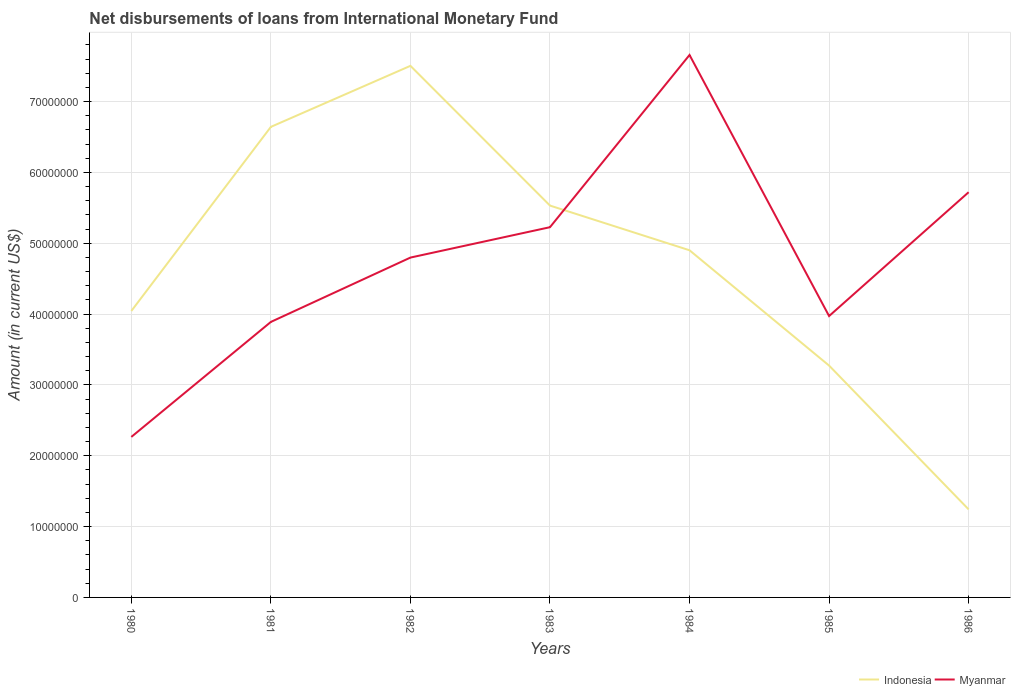Does the line corresponding to Myanmar intersect with the line corresponding to Indonesia?
Your answer should be compact. Yes. Across all years, what is the maximum amount of loans disbursed in Myanmar?
Provide a short and direct response. 2.27e+07. In which year was the amount of loans disbursed in Myanmar maximum?
Provide a short and direct response. 1980. What is the total amount of loans disbursed in Indonesia in the graph?
Give a very brief answer. 7.71e+06. What is the difference between the highest and the second highest amount of loans disbursed in Indonesia?
Give a very brief answer. 6.26e+07. Is the amount of loans disbursed in Indonesia strictly greater than the amount of loans disbursed in Myanmar over the years?
Offer a terse response. No. How many years are there in the graph?
Provide a short and direct response. 7. Does the graph contain grids?
Offer a terse response. Yes. Where does the legend appear in the graph?
Give a very brief answer. Bottom right. How are the legend labels stacked?
Provide a succinct answer. Horizontal. What is the title of the graph?
Make the answer very short. Net disbursements of loans from International Monetary Fund. What is the Amount (in current US$) in Indonesia in 1980?
Provide a short and direct response. 4.04e+07. What is the Amount (in current US$) of Myanmar in 1980?
Provide a succinct answer. 2.27e+07. What is the Amount (in current US$) of Indonesia in 1981?
Make the answer very short. 6.64e+07. What is the Amount (in current US$) in Myanmar in 1981?
Your answer should be very brief. 3.89e+07. What is the Amount (in current US$) in Indonesia in 1982?
Offer a very short reply. 7.50e+07. What is the Amount (in current US$) in Myanmar in 1982?
Offer a terse response. 4.80e+07. What is the Amount (in current US$) of Indonesia in 1983?
Keep it short and to the point. 5.53e+07. What is the Amount (in current US$) in Myanmar in 1983?
Your response must be concise. 5.23e+07. What is the Amount (in current US$) of Indonesia in 1984?
Make the answer very short. 4.90e+07. What is the Amount (in current US$) of Myanmar in 1984?
Ensure brevity in your answer.  7.66e+07. What is the Amount (in current US$) of Indonesia in 1985?
Give a very brief answer. 3.27e+07. What is the Amount (in current US$) of Myanmar in 1985?
Keep it short and to the point. 3.97e+07. What is the Amount (in current US$) of Indonesia in 1986?
Your answer should be very brief. 1.24e+07. What is the Amount (in current US$) in Myanmar in 1986?
Your response must be concise. 5.72e+07. Across all years, what is the maximum Amount (in current US$) of Indonesia?
Your response must be concise. 7.50e+07. Across all years, what is the maximum Amount (in current US$) of Myanmar?
Provide a succinct answer. 7.66e+07. Across all years, what is the minimum Amount (in current US$) in Indonesia?
Give a very brief answer. 1.24e+07. Across all years, what is the minimum Amount (in current US$) of Myanmar?
Offer a very short reply. 2.27e+07. What is the total Amount (in current US$) of Indonesia in the graph?
Offer a very short reply. 3.31e+08. What is the total Amount (in current US$) in Myanmar in the graph?
Your answer should be very brief. 3.35e+08. What is the difference between the Amount (in current US$) in Indonesia in 1980 and that in 1981?
Your answer should be very brief. -2.60e+07. What is the difference between the Amount (in current US$) in Myanmar in 1980 and that in 1981?
Offer a terse response. -1.62e+07. What is the difference between the Amount (in current US$) of Indonesia in 1980 and that in 1982?
Provide a succinct answer. -3.46e+07. What is the difference between the Amount (in current US$) of Myanmar in 1980 and that in 1982?
Your answer should be compact. -2.53e+07. What is the difference between the Amount (in current US$) of Indonesia in 1980 and that in 1983?
Make the answer very short. -1.49e+07. What is the difference between the Amount (in current US$) in Myanmar in 1980 and that in 1983?
Offer a very short reply. -2.96e+07. What is the difference between the Amount (in current US$) in Indonesia in 1980 and that in 1984?
Give a very brief answer. -8.57e+06. What is the difference between the Amount (in current US$) of Myanmar in 1980 and that in 1984?
Offer a very short reply. -5.39e+07. What is the difference between the Amount (in current US$) in Indonesia in 1980 and that in 1985?
Keep it short and to the point. 7.71e+06. What is the difference between the Amount (in current US$) in Myanmar in 1980 and that in 1985?
Your answer should be compact. -1.71e+07. What is the difference between the Amount (in current US$) in Indonesia in 1980 and that in 1986?
Your answer should be very brief. 2.80e+07. What is the difference between the Amount (in current US$) of Myanmar in 1980 and that in 1986?
Ensure brevity in your answer.  -3.45e+07. What is the difference between the Amount (in current US$) of Indonesia in 1981 and that in 1982?
Your answer should be very brief. -8.62e+06. What is the difference between the Amount (in current US$) in Myanmar in 1981 and that in 1982?
Your response must be concise. -9.08e+06. What is the difference between the Amount (in current US$) in Indonesia in 1981 and that in 1983?
Provide a short and direct response. 1.11e+07. What is the difference between the Amount (in current US$) of Myanmar in 1981 and that in 1983?
Make the answer very short. -1.34e+07. What is the difference between the Amount (in current US$) in Indonesia in 1981 and that in 1984?
Offer a terse response. 1.74e+07. What is the difference between the Amount (in current US$) in Myanmar in 1981 and that in 1984?
Your answer should be very brief. -3.77e+07. What is the difference between the Amount (in current US$) of Indonesia in 1981 and that in 1985?
Give a very brief answer. 3.37e+07. What is the difference between the Amount (in current US$) in Myanmar in 1981 and that in 1985?
Keep it short and to the point. -8.28e+05. What is the difference between the Amount (in current US$) in Indonesia in 1981 and that in 1986?
Provide a succinct answer. 5.40e+07. What is the difference between the Amount (in current US$) in Myanmar in 1981 and that in 1986?
Your answer should be compact. -1.83e+07. What is the difference between the Amount (in current US$) of Indonesia in 1982 and that in 1983?
Offer a terse response. 1.97e+07. What is the difference between the Amount (in current US$) of Myanmar in 1982 and that in 1983?
Offer a terse response. -4.29e+06. What is the difference between the Amount (in current US$) of Indonesia in 1982 and that in 1984?
Your answer should be compact. 2.60e+07. What is the difference between the Amount (in current US$) in Myanmar in 1982 and that in 1984?
Keep it short and to the point. -2.86e+07. What is the difference between the Amount (in current US$) of Indonesia in 1982 and that in 1985?
Provide a succinct answer. 4.23e+07. What is the difference between the Amount (in current US$) of Myanmar in 1982 and that in 1985?
Offer a terse response. 8.26e+06. What is the difference between the Amount (in current US$) in Indonesia in 1982 and that in 1986?
Provide a succinct answer. 6.26e+07. What is the difference between the Amount (in current US$) in Myanmar in 1982 and that in 1986?
Provide a succinct answer. -9.23e+06. What is the difference between the Amount (in current US$) in Indonesia in 1983 and that in 1984?
Ensure brevity in your answer.  6.31e+06. What is the difference between the Amount (in current US$) in Myanmar in 1983 and that in 1984?
Your answer should be very brief. -2.43e+07. What is the difference between the Amount (in current US$) in Indonesia in 1983 and that in 1985?
Ensure brevity in your answer.  2.26e+07. What is the difference between the Amount (in current US$) of Myanmar in 1983 and that in 1985?
Offer a very short reply. 1.25e+07. What is the difference between the Amount (in current US$) of Indonesia in 1983 and that in 1986?
Your response must be concise. 4.29e+07. What is the difference between the Amount (in current US$) in Myanmar in 1983 and that in 1986?
Ensure brevity in your answer.  -4.94e+06. What is the difference between the Amount (in current US$) in Indonesia in 1984 and that in 1985?
Provide a succinct answer. 1.63e+07. What is the difference between the Amount (in current US$) of Myanmar in 1984 and that in 1985?
Provide a short and direct response. 3.69e+07. What is the difference between the Amount (in current US$) in Indonesia in 1984 and that in 1986?
Make the answer very short. 3.66e+07. What is the difference between the Amount (in current US$) of Myanmar in 1984 and that in 1986?
Make the answer very short. 1.94e+07. What is the difference between the Amount (in current US$) of Indonesia in 1985 and that in 1986?
Make the answer very short. 2.03e+07. What is the difference between the Amount (in current US$) in Myanmar in 1985 and that in 1986?
Make the answer very short. -1.75e+07. What is the difference between the Amount (in current US$) in Indonesia in 1980 and the Amount (in current US$) in Myanmar in 1981?
Give a very brief answer. 1.54e+06. What is the difference between the Amount (in current US$) in Indonesia in 1980 and the Amount (in current US$) in Myanmar in 1982?
Offer a very short reply. -7.54e+06. What is the difference between the Amount (in current US$) of Indonesia in 1980 and the Amount (in current US$) of Myanmar in 1983?
Provide a short and direct response. -1.18e+07. What is the difference between the Amount (in current US$) of Indonesia in 1980 and the Amount (in current US$) of Myanmar in 1984?
Give a very brief answer. -3.61e+07. What is the difference between the Amount (in current US$) in Indonesia in 1980 and the Amount (in current US$) in Myanmar in 1985?
Provide a short and direct response. 7.14e+05. What is the difference between the Amount (in current US$) in Indonesia in 1980 and the Amount (in current US$) in Myanmar in 1986?
Offer a terse response. -1.68e+07. What is the difference between the Amount (in current US$) of Indonesia in 1981 and the Amount (in current US$) of Myanmar in 1982?
Your answer should be very brief. 1.85e+07. What is the difference between the Amount (in current US$) in Indonesia in 1981 and the Amount (in current US$) in Myanmar in 1983?
Ensure brevity in your answer.  1.42e+07. What is the difference between the Amount (in current US$) of Indonesia in 1981 and the Amount (in current US$) of Myanmar in 1984?
Make the answer very short. -1.01e+07. What is the difference between the Amount (in current US$) of Indonesia in 1981 and the Amount (in current US$) of Myanmar in 1985?
Make the answer very short. 2.67e+07. What is the difference between the Amount (in current US$) of Indonesia in 1981 and the Amount (in current US$) of Myanmar in 1986?
Offer a terse response. 9.22e+06. What is the difference between the Amount (in current US$) of Indonesia in 1982 and the Amount (in current US$) of Myanmar in 1983?
Provide a succinct answer. 2.28e+07. What is the difference between the Amount (in current US$) in Indonesia in 1982 and the Amount (in current US$) in Myanmar in 1984?
Give a very brief answer. -1.53e+06. What is the difference between the Amount (in current US$) of Indonesia in 1982 and the Amount (in current US$) of Myanmar in 1985?
Provide a succinct answer. 3.53e+07. What is the difference between the Amount (in current US$) of Indonesia in 1982 and the Amount (in current US$) of Myanmar in 1986?
Offer a terse response. 1.78e+07. What is the difference between the Amount (in current US$) in Indonesia in 1983 and the Amount (in current US$) in Myanmar in 1984?
Give a very brief answer. -2.13e+07. What is the difference between the Amount (in current US$) of Indonesia in 1983 and the Amount (in current US$) of Myanmar in 1985?
Your answer should be compact. 1.56e+07. What is the difference between the Amount (in current US$) of Indonesia in 1983 and the Amount (in current US$) of Myanmar in 1986?
Your answer should be compact. -1.89e+06. What is the difference between the Amount (in current US$) in Indonesia in 1984 and the Amount (in current US$) in Myanmar in 1985?
Provide a succinct answer. 9.29e+06. What is the difference between the Amount (in current US$) in Indonesia in 1984 and the Amount (in current US$) in Myanmar in 1986?
Make the answer very short. -8.20e+06. What is the difference between the Amount (in current US$) in Indonesia in 1985 and the Amount (in current US$) in Myanmar in 1986?
Keep it short and to the point. -2.45e+07. What is the average Amount (in current US$) in Indonesia per year?
Provide a succinct answer. 4.73e+07. What is the average Amount (in current US$) of Myanmar per year?
Provide a short and direct response. 4.79e+07. In the year 1980, what is the difference between the Amount (in current US$) in Indonesia and Amount (in current US$) in Myanmar?
Your answer should be very brief. 1.78e+07. In the year 1981, what is the difference between the Amount (in current US$) of Indonesia and Amount (in current US$) of Myanmar?
Make the answer very short. 2.75e+07. In the year 1982, what is the difference between the Amount (in current US$) in Indonesia and Amount (in current US$) in Myanmar?
Ensure brevity in your answer.  2.71e+07. In the year 1983, what is the difference between the Amount (in current US$) in Indonesia and Amount (in current US$) in Myanmar?
Keep it short and to the point. 3.05e+06. In the year 1984, what is the difference between the Amount (in current US$) in Indonesia and Amount (in current US$) in Myanmar?
Make the answer very short. -2.76e+07. In the year 1985, what is the difference between the Amount (in current US$) in Indonesia and Amount (in current US$) in Myanmar?
Your answer should be very brief. -6.99e+06. In the year 1986, what is the difference between the Amount (in current US$) of Indonesia and Amount (in current US$) of Myanmar?
Keep it short and to the point. -4.48e+07. What is the ratio of the Amount (in current US$) in Indonesia in 1980 to that in 1981?
Your response must be concise. 0.61. What is the ratio of the Amount (in current US$) in Myanmar in 1980 to that in 1981?
Provide a short and direct response. 0.58. What is the ratio of the Amount (in current US$) of Indonesia in 1980 to that in 1982?
Your response must be concise. 0.54. What is the ratio of the Amount (in current US$) in Myanmar in 1980 to that in 1982?
Your response must be concise. 0.47. What is the ratio of the Amount (in current US$) in Indonesia in 1980 to that in 1983?
Offer a very short reply. 0.73. What is the ratio of the Amount (in current US$) of Myanmar in 1980 to that in 1983?
Make the answer very short. 0.43. What is the ratio of the Amount (in current US$) of Indonesia in 1980 to that in 1984?
Your answer should be compact. 0.83. What is the ratio of the Amount (in current US$) of Myanmar in 1980 to that in 1984?
Offer a terse response. 0.3. What is the ratio of the Amount (in current US$) of Indonesia in 1980 to that in 1985?
Make the answer very short. 1.24. What is the ratio of the Amount (in current US$) in Myanmar in 1980 to that in 1985?
Your answer should be compact. 0.57. What is the ratio of the Amount (in current US$) of Indonesia in 1980 to that in 1986?
Your response must be concise. 3.25. What is the ratio of the Amount (in current US$) of Myanmar in 1980 to that in 1986?
Provide a succinct answer. 0.4. What is the ratio of the Amount (in current US$) of Indonesia in 1981 to that in 1982?
Offer a very short reply. 0.89. What is the ratio of the Amount (in current US$) in Myanmar in 1981 to that in 1982?
Your answer should be very brief. 0.81. What is the ratio of the Amount (in current US$) of Indonesia in 1981 to that in 1983?
Your answer should be compact. 1.2. What is the ratio of the Amount (in current US$) of Myanmar in 1981 to that in 1983?
Give a very brief answer. 0.74. What is the ratio of the Amount (in current US$) of Indonesia in 1981 to that in 1984?
Make the answer very short. 1.36. What is the ratio of the Amount (in current US$) of Myanmar in 1981 to that in 1984?
Give a very brief answer. 0.51. What is the ratio of the Amount (in current US$) in Indonesia in 1981 to that in 1985?
Offer a terse response. 2.03. What is the ratio of the Amount (in current US$) in Myanmar in 1981 to that in 1985?
Offer a terse response. 0.98. What is the ratio of the Amount (in current US$) in Indonesia in 1981 to that in 1986?
Offer a very short reply. 5.35. What is the ratio of the Amount (in current US$) in Myanmar in 1981 to that in 1986?
Ensure brevity in your answer.  0.68. What is the ratio of the Amount (in current US$) in Indonesia in 1982 to that in 1983?
Your answer should be compact. 1.36. What is the ratio of the Amount (in current US$) in Myanmar in 1982 to that in 1983?
Your answer should be compact. 0.92. What is the ratio of the Amount (in current US$) in Indonesia in 1982 to that in 1984?
Provide a short and direct response. 1.53. What is the ratio of the Amount (in current US$) of Myanmar in 1982 to that in 1984?
Your answer should be compact. 0.63. What is the ratio of the Amount (in current US$) of Indonesia in 1982 to that in 1985?
Give a very brief answer. 2.29. What is the ratio of the Amount (in current US$) in Myanmar in 1982 to that in 1985?
Give a very brief answer. 1.21. What is the ratio of the Amount (in current US$) of Indonesia in 1982 to that in 1986?
Provide a short and direct response. 6.04. What is the ratio of the Amount (in current US$) in Myanmar in 1982 to that in 1986?
Offer a very short reply. 0.84. What is the ratio of the Amount (in current US$) in Indonesia in 1983 to that in 1984?
Provide a succinct answer. 1.13. What is the ratio of the Amount (in current US$) of Myanmar in 1983 to that in 1984?
Offer a terse response. 0.68. What is the ratio of the Amount (in current US$) of Indonesia in 1983 to that in 1985?
Keep it short and to the point. 1.69. What is the ratio of the Amount (in current US$) of Myanmar in 1983 to that in 1985?
Offer a terse response. 1.32. What is the ratio of the Amount (in current US$) in Indonesia in 1983 to that in 1986?
Offer a terse response. 4.45. What is the ratio of the Amount (in current US$) of Myanmar in 1983 to that in 1986?
Offer a terse response. 0.91. What is the ratio of the Amount (in current US$) of Indonesia in 1984 to that in 1985?
Provide a short and direct response. 1.5. What is the ratio of the Amount (in current US$) in Myanmar in 1984 to that in 1985?
Keep it short and to the point. 1.93. What is the ratio of the Amount (in current US$) of Indonesia in 1984 to that in 1986?
Provide a succinct answer. 3.94. What is the ratio of the Amount (in current US$) in Myanmar in 1984 to that in 1986?
Provide a short and direct response. 1.34. What is the ratio of the Amount (in current US$) in Indonesia in 1985 to that in 1986?
Ensure brevity in your answer.  2.63. What is the ratio of the Amount (in current US$) of Myanmar in 1985 to that in 1986?
Provide a short and direct response. 0.69. What is the difference between the highest and the second highest Amount (in current US$) in Indonesia?
Provide a short and direct response. 8.62e+06. What is the difference between the highest and the second highest Amount (in current US$) in Myanmar?
Provide a short and direct response. 1.94e+07. What is the difference between the highest and the lowest Amount (in current US$) of Indonesia?
Make the answer very short. 6.26e+07. What is the difference between the highest and the lowest Amount (in current US$) of Myanmar?
Make the answer very short. 5.39e+07. 